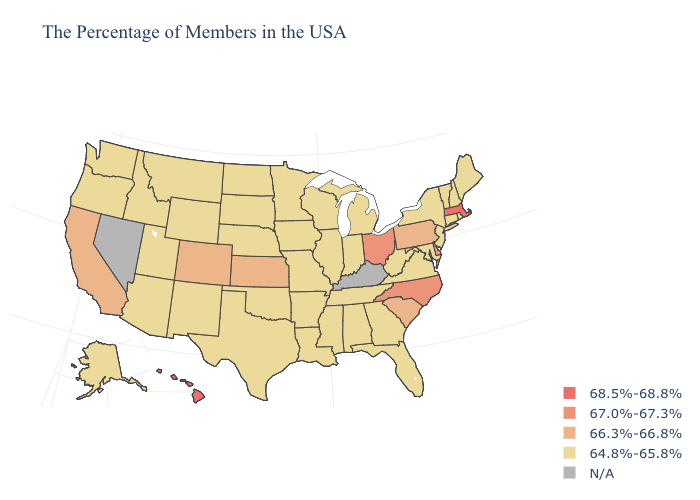What is the highest value in states that border Massachusetts?
Short answer required. 64.8%-65.8%. What is the value of Ohio?
Concise answer only. 67.0%-67.3%. Does North Carolina have the lowest value in the USA?
Concise answer only. No. What is the lowest value in the MidWest?
Keep it brief. 64.8%-65.8%. What is the highest value in the MidWest ?
Concise answer only. 67.0%-67.3%. Among the states that border Pennsylvania , which have the lowest value?
Give a very brief answer. New York, New Jersey, Maryland, West Virginia. Name the states that have a value in the range 66.3%-66.8%?
Short answer required. Pennsylvania, South Carolina, Kansas, Colorado, California. Among the states that border West Virginia , does Ohio have the highest value?
Be succinct. Yes. Does Georgia have the highest value in the USA?
Answer briefly. No. Does Massachusetts have the highest value in the USA?
Short answer required. Yes. Which states have the lowest value in the USA?
Give a very brief answer. Maine, Rhode Island, New Hampshire, Vermont, Connecticut, New York, New Jersey, Maryland, Virginia, West Virginia, Florida, Georgia, Michigan, Indiana, Alabama, Tennessee, Wisconsin, Illinois, Mississippi, Louisiana, Missouri, Arkansas, Minnesota, Iowa, Nebraska, Oklahoma, Texas, South Dakota, North Dakota, Wyoming, New Mexico, Utah, Montana, Arizona, Idaho, Washington, Oregon, Alaska. Does Hawaii have the lowest value in the West?
Keep it brief. No. What is the value of Connecticut?
Be succinct. 64.8%-65.8%. Does Hawaii have the highest value in the USA?
Quick response, please. Yes. What is the value of Pennsylvania?
Write a very short answer. 66.3%-66.8%. 